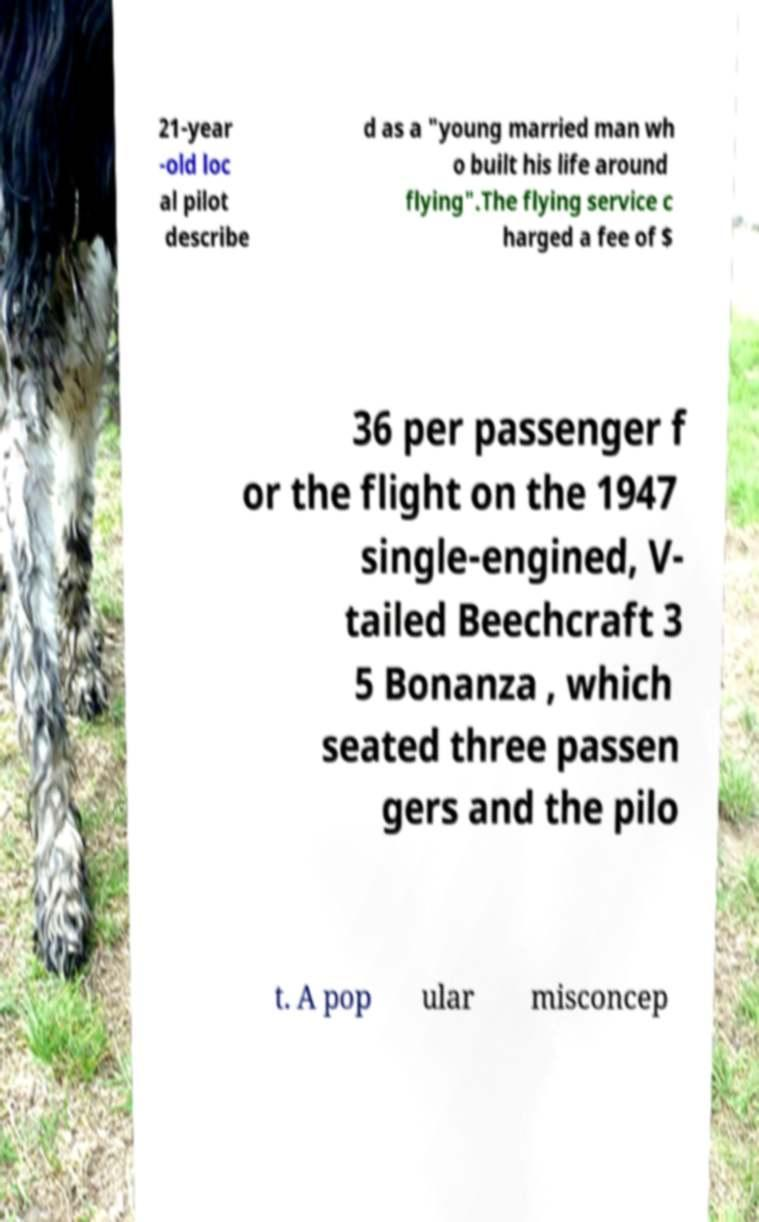I need the written content from this picture converted into text. Can you do that? 21-year -old loc al pilot describe d as a "young married man wh o built his life around flying".The flying service c harged a fee of $ 36 per passenger f or the flight on the 1947 single-engined, V- tailed Beechcraft 3 5 Bonanza , which seated three passen gers and the pilo t. A pop ular misconcep 